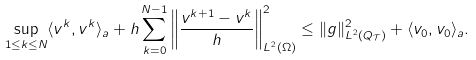Convert formula to latex. <formula><loc_0><loc_0><loc_500><loc_500>\sup _ { 1 \leq k \leq N } \langle v ^ { k } , v ^ { k } \rangle _ { a } + h \sum _ { k = 0 } ^ { N - 1 } \left \| \frac { v ^ { k + 1 } - v ^ { k } } { h } \right \| _ { L ^ { 2 } ( \Omega ) } ^ { 2 } \leq \| g \| _ { L ^ { 2 } ( Q _ { \mathcal { T } } ) } ^ { 2 } + \langle v _ { 0 } , v _ { 0 } \rangle _ { a } .</formula> 